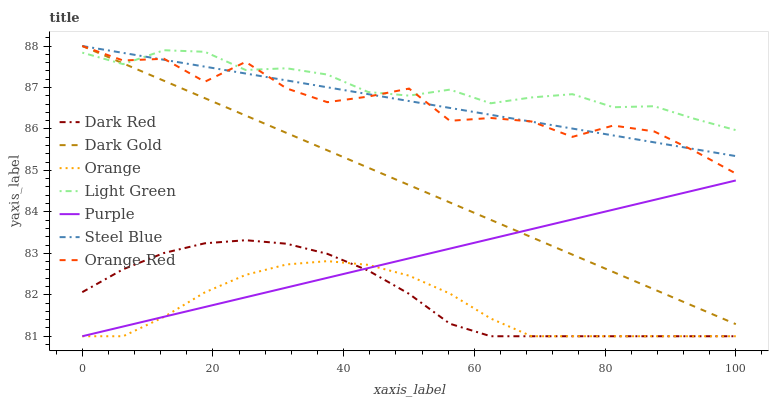Does Orange have the minimum area under the curve?
Answer yes or no. Yes. Does Light Green have the maximum area under the curve?
Answer yes or no. Yes. Does Purple have the minimum area under the curve?
Answer yes or no. No. Does Purple have the maximum area under the curve?
Answer yes or no. No. Is Purple the smoothest?
Answer yes or no. Yes. Is Orange Red the roughest?
Answer yes or no. Yes. Is Dark Red the smoothest?
Answer yes or no. No. Is Dark Red the roughest?
Answer yes or no. No. Does Steel Blue have the lowest value?
Answer yes or no. No. Does Orange Red have the highest value?
Answer yes or no. Yes. Does Purple have the highest value?
Answer yes or no. No. Is Orange less than Orange Red?
Answer yes or no. Yes. Is Steel Blue greater than Orange?
Answer yes or no. Yes. Does Steel Blue intersect Dark Gold?
Answer yes or no. Yes. Is Steel Blue less than Dark Gold?
Answer yes or no. No. Is Steel Blue greater than Dark Gold?
Answer yes or no. No. Does Orange intersect Orange Red?
Answer yes or no. No. 